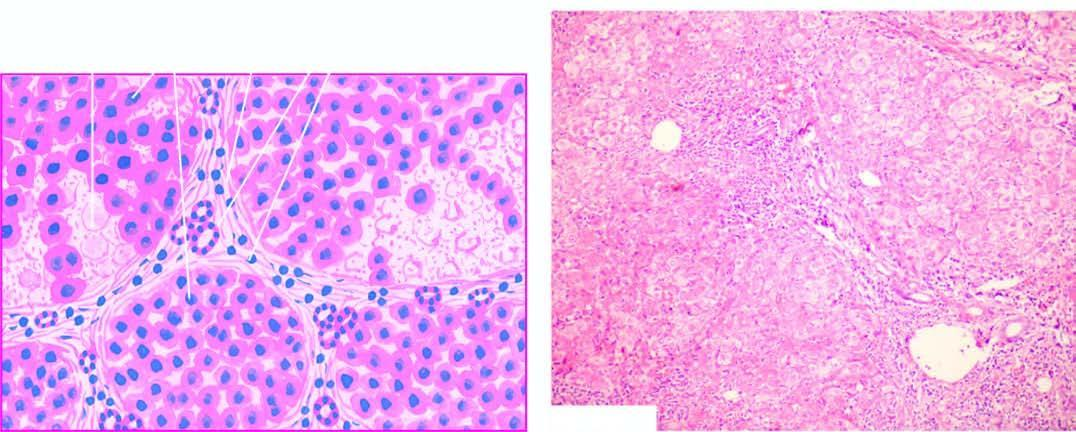do a few intact hepatic lobules remain?
Answer the question using a single word or phrase. Yes 